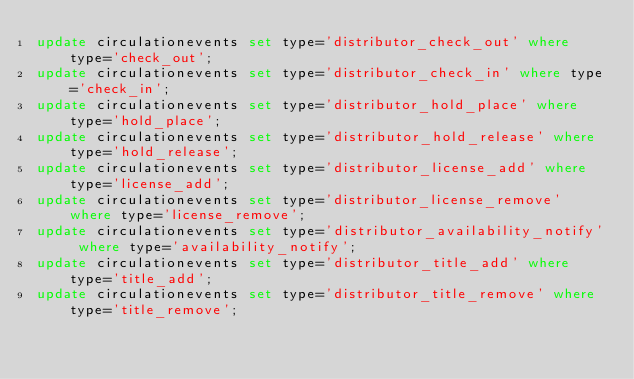<code> <loc_0><loc_0><loc_500><loc_500><_SQL_>update circulationevents set type='distributor_check_out' where type='check_out';
update circulationevents set type='distributor_check_in' where type='check_in';
update circulationevents set type='distributor_hold_place' where type='hold_place';
update circulationevents set type='distributor_hold_release' where type='hold_release';
update circulationevents set type='distributor_license_add' where type='license_add';
update circulationevents set type='distributor_license_remove' where type='license_remove';
update circulationevents set type='distributor_availability_notify' where type='availability_notify';
update circulationevents set type='distributor_title_add' where type='title_add';
update circulationevents set type='distributor_title_remove' where type='title_remove';</code> 